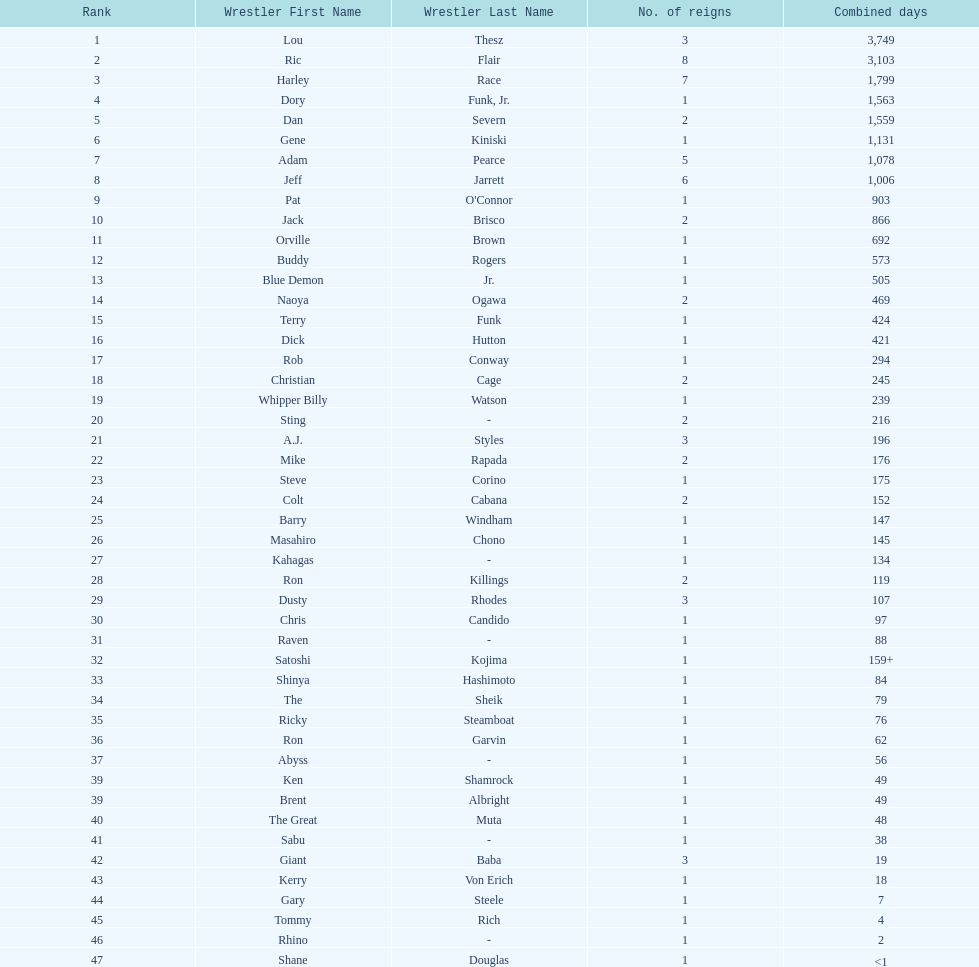How long did orville brown remain nwa world heavyweight champion? 692 days. 